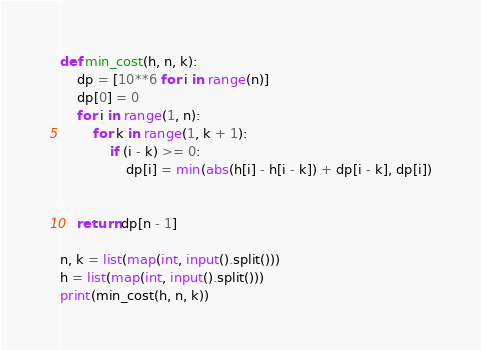<code> <loc_0><loc_0><loc_500><loc_500><_Python_>def min_cost(h, n, k):
    dp = [10**6 for i in range(n)]
    dp[0] = 0
    for i in range(1, n):
        for k in range(1, k + 1):
            if (i - k) >= 0:
                dp[i] = min(abs(h[i] - h[i - k]) + dp[i - k], dp[i])


    return dp[n - 1] 

n, k = list(map(int, input().split()))
h = list(map(int, input().split()))
print(min_cost(h, n, k))

</code> 